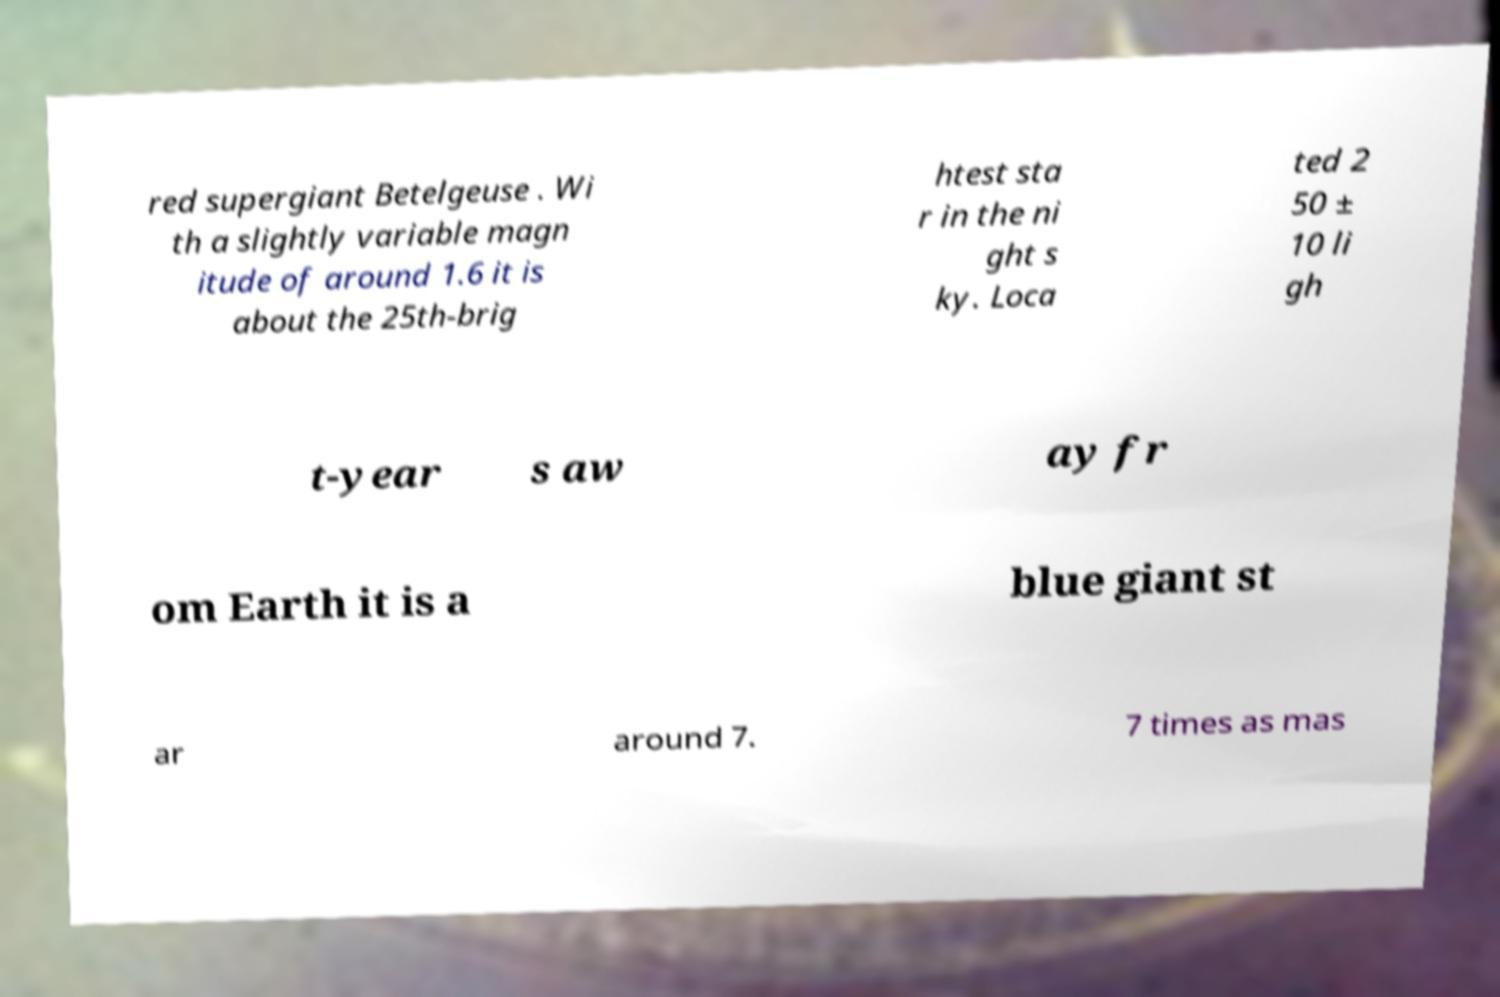I need the written content from this picture converted into text. Can you do that? red supergiant Betelgeuse . Wi th a slightly variable magn itude of around 1.6 it is about the 25th-brig htest sta r in the ni ght s ky. Loca ted 2 50 ± 10 li gh t-year s aw ay fr om Earth it is a blue giant st ar around 7. 7 times as mas 